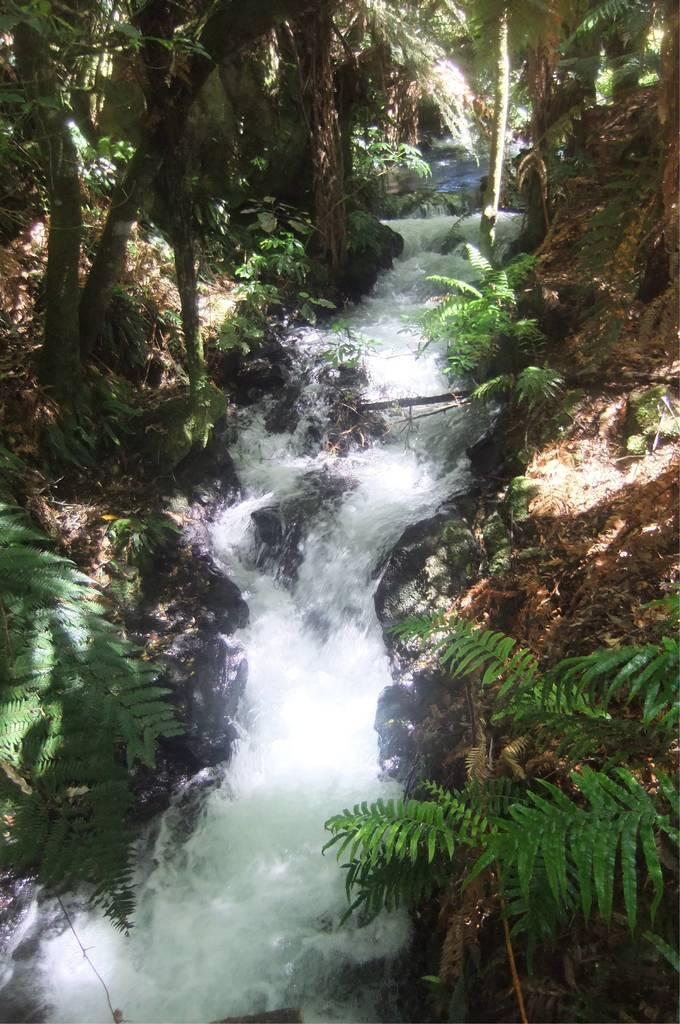What is happening on the ground in the image? There is water flowing on the ground in the image. What can be seen on either side of the water in the image? Trees are present on either side of the water in the image. Where is the ring being sold in the image? There is no ring or market present in the image; it features water flowing on the ground with trees on either side. 